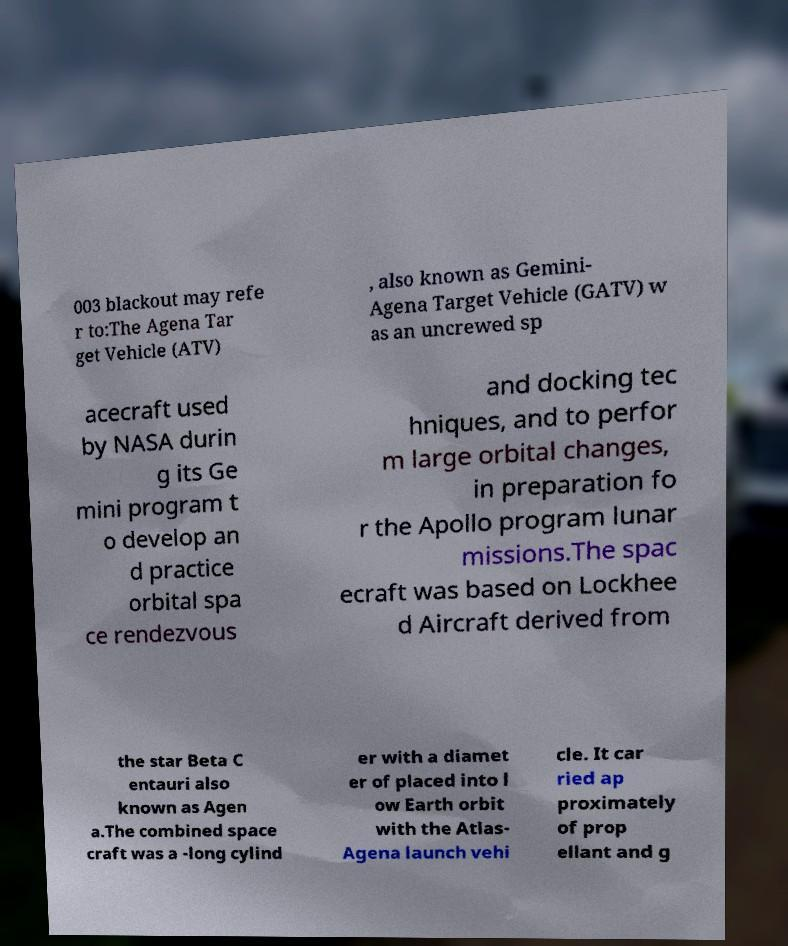Can you read and provide the text displayed in the image?This photo seems to have some interesting text. Can you extract and type it out for me? 003 blackout may refe r to:The Agena Tar get Vehicle (ATV) , also known as Gemini- Agena Target Vehicle (GATV) w as an uncrewed sp acecraft used by NASA durin g its Ge mini program t o develop an d practice orbital spa ce rendezvous and docking tec hniques, and to perfor m large orbital changes, in preparation fo r the Apollo program lunar missions.The spac ecraft was based on Lockhee d Aircraft derived from the star Beta C entauri also known as Agen a.The combined space craft was a -long cylind er with a diamet er of placed into l ow Earth orbit with the Atlas- Agena launch vehi cle. It car ried ap proximately of prop ellant and g 